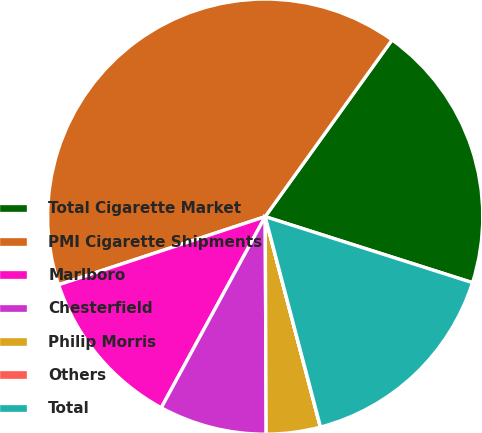Convert chart. <chart><loc_0><loc_0><loc_500><loc_500><pie_chart><fcel>Total Cigarette Market<fcel>PMI Cigarette Shipments<fcel>Marlboro<fcel>Chesterfield<fcel>Philip Morris<fcel>Others<fcel>Total<nl><fcel>20.0%<fcel>39.98%<fcel>12.0%<fcel>8.0%<fcel>4.01%<fcel>0.01%<fcel>16.0%<nl></chart> 